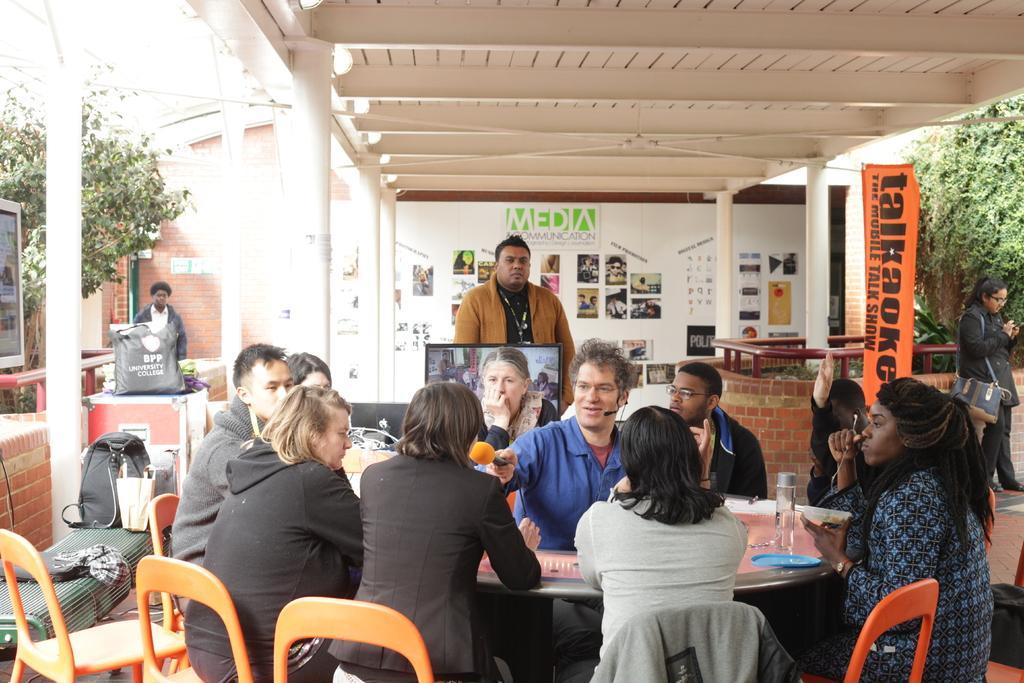In one or two sentences, can you explain what this image depicts? In this picture we can see a group of people where some are sitting on chair holding mic in their hand and talking and in background we can see pillar, wall with posters, banner, tree, some persons standing, bags, scarf on table. 